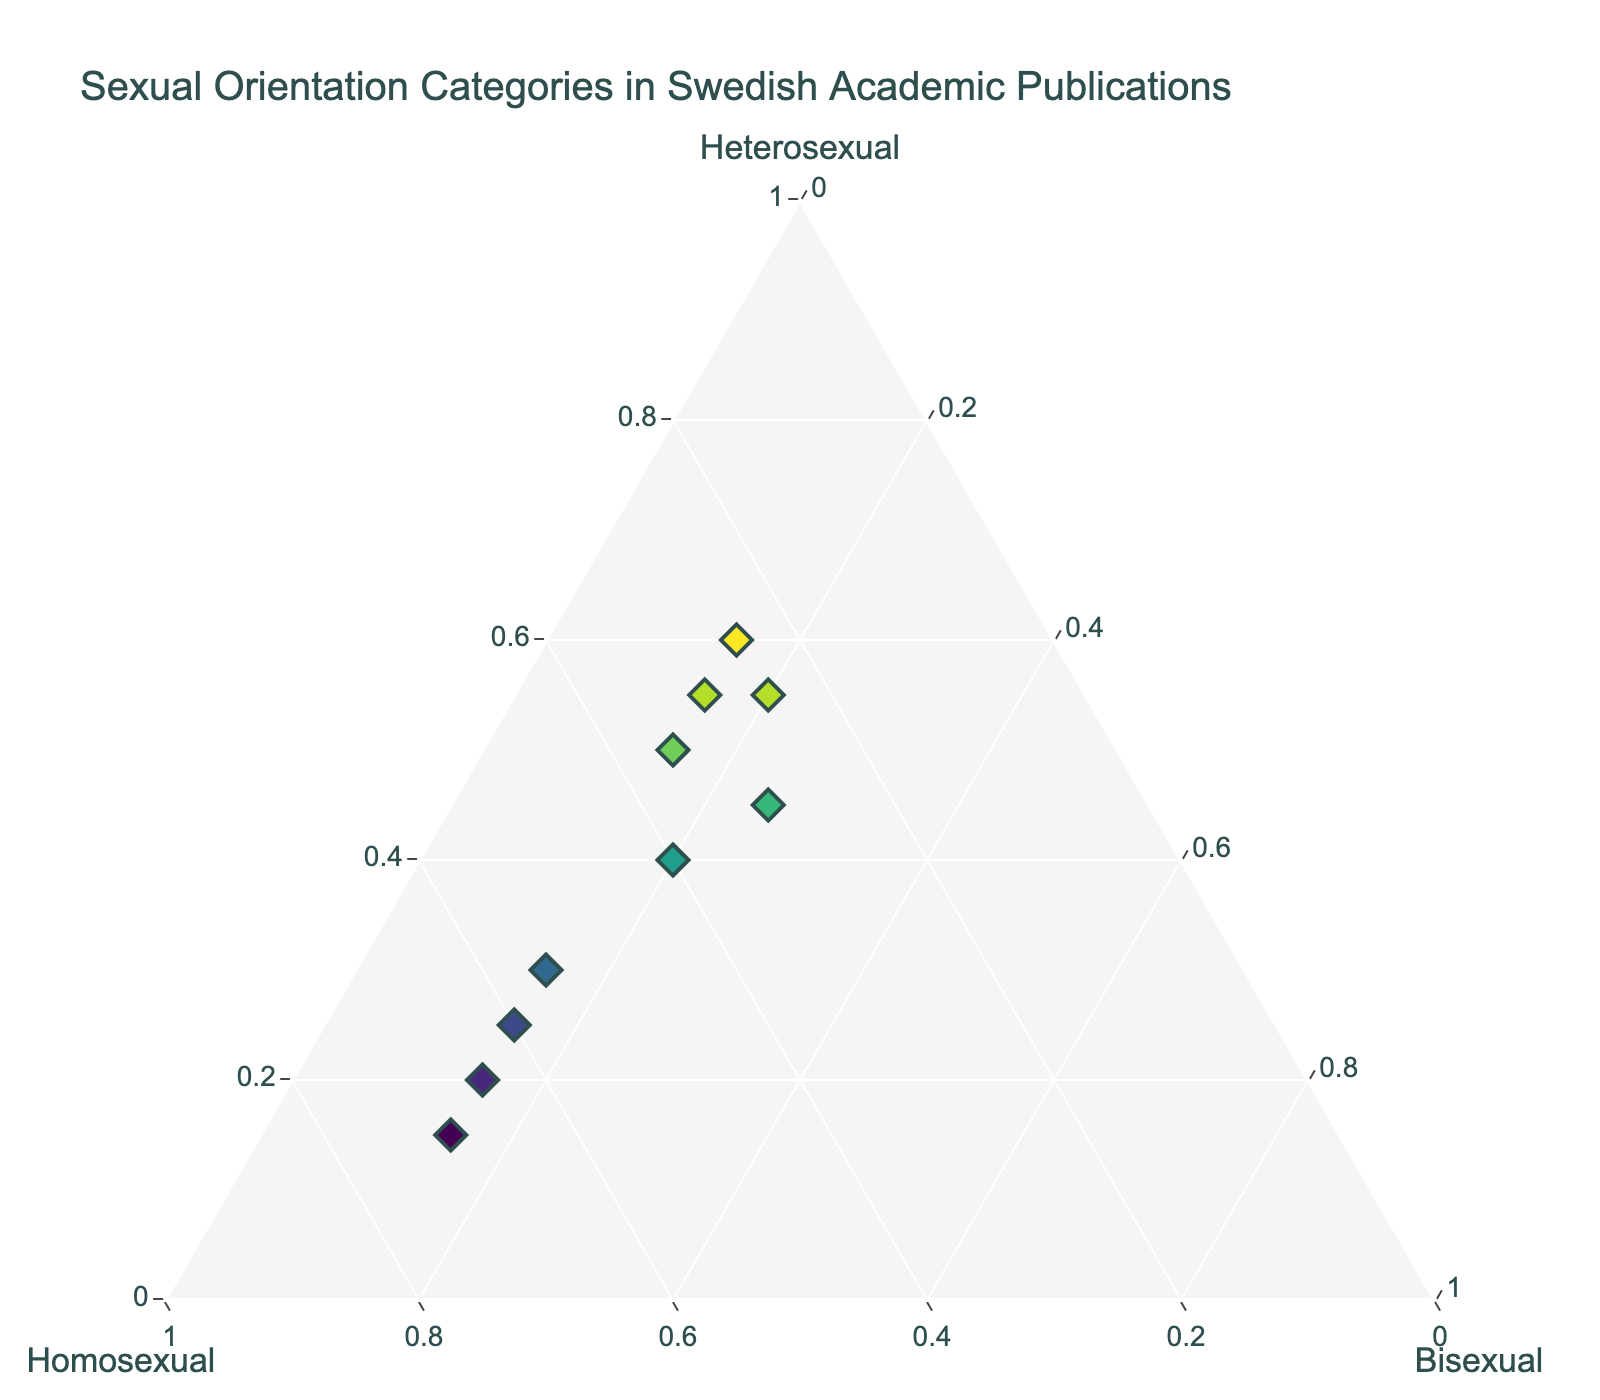How many publications focus more on the category "Homosexual" than "Heterosexual"? To find the answer, check the visual points where the 'Homosexual' axis value is higher than the 'Heterosexual' axis value. Publications meeting this criterion are "Queer Studies Quarterly", "Scandinavian LGBTQ+ Review", "Stockholm LGBTQ+ Perspectives", and "Malmö Queer Research".
Answer: 4 Which publication has the highest focus on "Homosexual" category? Identify the publication where 'Homosexual' axis value is the highest. "Scandinavian LGBTQ+ Review" has the highest value at 70%.
Answer: "Scandinavian LGBTQ+ Review" Are there any publications with equal focus on "Heterosexual" and "Bisexual" categories? Look for data points where the 'Heterosexual' and 'Bisexual' axis values are the same. No such points exist in the plot as all values differ across publications.
Answer: None Which publication has the most balanced focus across all three categories? Check for the publication whose data points are closest to being equidistant from all three vertices (an indication of balance). "Nordic Journal of Sexuality" with values 45 (Heterosexual), 30 (Homosexual), and 25 (Bisexual) is the most balanced.
Answer: "Nordic Journal of Sexuality" What is the total percentage focus on "Bisexual" across all publications? Sum all 'Bisexual' axis values from each publication: 15 + 15 + 25 + 15 + 15 + 15 + 20 + 15 + 20 + 15 = 170%.
Answer: 170% Which publication has the lowest focus on "Bisexual" category? Check the publication(s) where 'Bisexual' axis value is the smallest. Each publication has a minimum value for 'Bisexual' of 15%.
Answer: Multiple publications How many publications have a higher focus on "Heterosexual" category than the combined focus on "Homosexual" and "Bisexual"? Calculate for each publication if 'Heterosexual' > ('Homosexual' + 'Bisexual'). Publications meeting this criterion are "Gender & Society in Sweden" and "Lund University Gender Review.
Answer: 2 Which axis has the highest minimum value across all publications? Compare the minimum values of 'Heterosexual', 'Homosexual', and 'Bisexual' across all publications: Heterosexual (15), Homosexual (25), Bisexual (15). Thus, Homosexual has the highest minimum value at 25.
Answer: Homosexual What is the average focus on the "Homosexual" category? Calculate the average of 'Homosexual' values. Sum is 25 + 65 + 30 + 70 + 30 + 35 + 40 + 60 + 25 + 55 = 435. The average is 435/10 = 43.5.
Answer: 43.5 